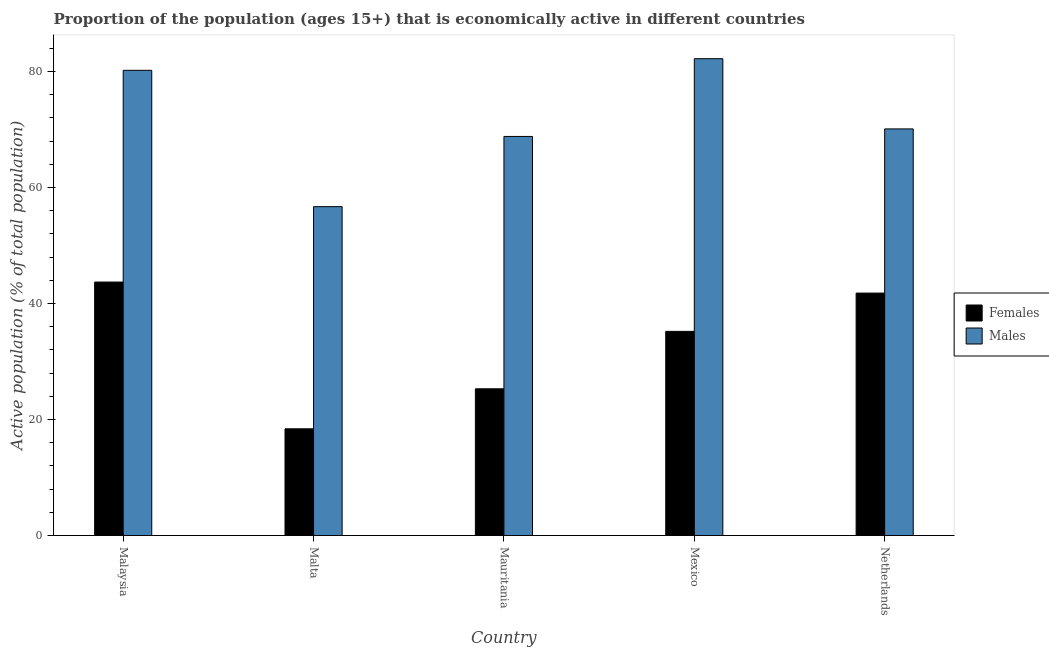How many groups of bars are there?
Provide a short and direct response. 5. What is the label of the 3rd group of bars from the left?
Provide a short and direct response. Mauritania. In how many cases, is the number of bars for a given country not equal to the number of legend labels?
Provide a succinct answer. 0. What is the percentage of economically active male population in Netherlands?
Provide a succinct answer. 70.1. Across all countries, what is the maximum percentage of economically active male population?
Your response must be concise. 82.2. Across all countries, what is the minimum percentage of economically active male population?
Keep it short and to the point. 56.7. In which country was the percentage of economically active male population maximum?
Offer a very short reply. Mexico. In which country was the percentage of economically active male population minimum?
Offer a terse response. Malta. What is the total percentage of economically active male population in the graph?
Keep it short and to the point. 358. What is the difference between the percentage of economically active female population in Mexico and the percentage of economically active male population in Mauritania?
Make the answer very short. -33.6. What is the average percentage of economically active male population per country?
Offer a very short reply. 71.6. What is the difference between the percentage of economically active male population and percentage of economically active female population in Malaysia?
Give a very brief answer. 36.5. In how many countries, is the percentage of economically active female population greater than 28 %?
Your response must be concise. 3. What is the ratio of the percentage of economically active male population in Mauritania to that in Mexico?
Provide a short and direct response. 0.84. Is the percentage of economically active female population in Malta less than that in Mexico?
Keep it short and to the point. Yes. What is the difference between the highest and the second highest percentage of economically active female population?
Your answer should be very brief. 1.9. What is the difference between the highest and the lowest percentage of economically active male population?
Provide a succinct answer. 25.5. In how many countries, is the percentage of economically active male population greater than the average percentage of economically active male population taken over all countries?
Give a very brief answer. 2. What does the 2nd bar from the left in Malaysia represents?
Give a very brief answer. Males. What does the 1st bar from the right in Mauritania represents?
Your answer should be compact. Males. How many bars are there?
Provide a short and direct response. 10. What is the difference between two consecutive major ticks on the Y-axis?
Your answer should be very brief. 20. Does the graph contain any zero values?
Your answer should be compact. No. What is the title of the graph?
Ensure brevity in your answer.  Proportion of the population (ages 15+) that is economically active in different countries. Does "Lower secondary education" appear as one of the legend labels in the graph?
Offer a very short reply. No. What is the label or title of the X-axis?
Provide a succinct answer. Country. What is the label or title of the Y-axis?
Keep it short and to the point. Active population (% of total population). What is the Active population (% of total population) of Females in Malaysia?
Provide a short and direct response. 43.7. What is the Active population (% of total population) of Males in Malaysia?
Your response must be concise. 80.2. What is the Active population (% of total population) in Females in Malta?
Provide a succinct answer. 18.4. What is the Active population (% of total population) of Males in Malta?
Give a very brief answer. 56.7. What is the Active population (% of total population) in Females in Mauritania?
Ensure brevity in your answer.  25.3. What is the Active population (% of total population) in Males in Mauritania?
Keep it short and to the point. 68.8. What is the Active population (% of total population) in Females in Mexico?
Make the answer very short. 35.2. What is the Active population (% of total population) in Males in Mexico?
Your response must be concise. 82.2. What is the Active population (% of total population) in Females in Netherlands?
Provide a short and direct response. 41.8. What is the Active population (% of total population) of Males in Netherlands?
Give a very brief answer. 70.1. Across all countries, what is the maximum Active population (% of total population) of Females?
Provide a short and direct response. 43.7. Across all countries, what is the maximum Active population (% of total population) in Males?
Keep it short and to the point. 82.2. Across all countries, what is the minimum Active population (% of total population) in Females?
Offer a terse response. 18.4. Across all countries, what is the minimum Active population (% of total population) of Males?
Your answer should be compact. 56.7. What is the total Active population (% of total population) of Females in the graph?
Ensure brevity in your answer.  164.4. What is the total Active population (% of total population) in Males in the graph?
Offer a very short reply. 358. What is the difference between the Active population (% of total population) of Females in Malaysia and that in Malta?
Give a very brief answer. 25.3. What is the difference between the Active population (% of total population) of Males in Malaysia and that in Malta?
Offer a very short reply. 23.5. What is the difference between the Active population (% of total population) in Females in Malaysia and that in Mauritania?
Ensure brevity in your answer.  18.4. What is the difference between the Active population (% of total population) in Males in Malaysia and that in Mauritania?
Your response must be concise. 11.4. What is the difference between the Active population (% of total population) of Females in Malaysia and that in Mexico?
Your answer should be compact. 8.5. What is the difference between the Active population (% of total population) in Males in Malaysia and that in Mexico?
Provide a succinct answer. -2. What is the difference between the Active population (% of total population) in Males in Malaysia and that in Netherlands?
Provide a succinct answer. 10.1. What is the difference between the Active population (% of total population) in Males in Malta and that in Mauritania?
Provide a short and direct response. -12.1. What is the difference between the Active population (% of total population) in Females in Malta and that in Mexico?
Offer a terse response. -16.8. What is the difference between the Active population (% of total population) in Males in Malta and that in Mexico?
Make the answer very short. -25.5. What is the difference between the Active population (% of total population) in Females in Malta and that in Netherlands?
Give a very brief answer. -23.4. What is the difference between the Active population (% of total population) in Males in Malta and that in Netherlands?
Your answer should be very brief. -13.4. What is the difference between the Active population (% of total population) of Females in Mauritania and that in Mexico?
Your answer should be compact. -9.9. What is the difference between the Active population (% of total population) in Females in Mauritania and that in Netherlands?
Provide a succinct answer. -16.5. What is the difference between the Active population (% of total population) of Males in Mauritania and that in Netherlands?
Your answer should be compact. -1.3. What is the difference between the Active population (% of total population) of Females in Malaysia and the Active population (% of total population) of Males in Malta?
Offer a very short reply. -13. What is the difference between the Active population (% of total population) of Females in Malaysia and the Active population (% of total population) of Males in Mauritania?
Offer a terse response. -25.1. What is the difference between the Active population (% of total population) in Females in Malaysia and the Active population (% of total population) in Males in Mexico?
Provide a succinct answer. -38.5. What is the difference between the Active population (% of total population) of Females in Malaysia and the Active population (% of total population) of Males in Netherlands?
Your answer should be very brief. -26.4. What is the difference between the Active population (% of total population) of Females in Malta and the Active population (% of total population) of Males in Mauritania?
Your answer should be very brief. -50.4. What is the difference between the Active population (% of total population) of Females in Malta and the Active population (% of total population) of Males in Mexico?
Make the answer very short. -63.8. What is the difference between the Active population (% of total population) of Females in Malta and the Active population (% of total population) of Males in Netherlands?
Make the answer very short. -51.7. What is the difference between the Active population (% of total population) of Females in Mauritania and the Active population (% of total population) of Males in Mexico?
Your answer should be compact. -56.9. What is the difference between the Active population (% of total population) in Females in Mauritania and the Active population (% of total population) in Males in Netherlands?
Ensure brevity in your answer.  -44.8. What is the difference between the Active population (% of total population) of Females in Mexico and the Active population (% of total population) of Males in Netherlands?
Give a very brief answer. -34.9. What is the average Active population (% of total population) of Females per country?
Your response must be concise. 32.88. What is the average Active population (% of total population) in Males per country?
Provide a short and direct response. 71.6. What is the difference between the Active population (% of total population) in Females and Active population (% of total population) in Males in Malaysia?
Offer a very short reply. -36.5. What is the difference between the Active population (% of total population) in Females and Active population (% of total population) in Males in Malta?
Make the answer very short. -38.3. What is the difference between the Active population (% of total population) of Females and Active population (% of total population) of Males in Mauritania?
Give a very brief answer. -43.5. What is the difference between the Active population (% of total population) in Females and Active population (% of total population) in Males in Mexico?
Make the answer very short. -47. What is the difference between the Active population (% of total population) in Females and Active population (% of total population) in Males in Netherlands?
Provide a short and direct response. -28.3. What is the ratio of the Active population (% of total population) in Females in Malaysia to that in Malta?
Ensure brevity in your answer.  2.38. What is the ratio of the Active population (% of total population) in Males in Malaysia to that in Malta?
Your answer should be compact. 1.41. What is the ratio of the Active population (% of total population) of Females in Malaysia to that in Mauritania?
Ensure brevity in your answer.  1.73. What is the ratio of the Active population (% of total population) in Males in Malaysia to that in Mauritania?
Your response must be concise. 1.17. What is the ratio of the Active population (% of total population) of Females in Malaysia to that in Mexico?
Provide a succinct answer. 1.24. What is the ratio of the Active population (% of total population) of Males in Malaysia to that in Mexico?
Keep it short and to the point. 0.98. What is the ratio of the Active population (% of total population) of Females in Malaysia to that in Netherlands?
Ensure brevity in your answer.  1.05. What is the ratio of the Active population (% of total population) in Males in Malaysia to that in Netherlands?
Ensure brevity in your answer.  1.14. What is the ratio of the Active population (% of total population) in Females in Malta to that in Mauritania?
Give a very brief answer. 0.73. What is the ratio of the Active population (% of total population) in Males in Malta to that in Mauritania?
Offer a very short reply. 0.82. What is the ratio of the Active population (% of total population) in Females in Malta to that in Mexico?
Provide a short and direct response. 0.52. What is the ratio of the Active population (% of total population) of Males in Malta to that in Mexico?
Offer a terse response. 0.69. What is the ratio of the Active population (% of total population) in Females in Malta to that in Netherlands?
Offer a terse response. 0.44. What is the ratio of the Active population (% of total population) of Males in Malta to that in Netherlands?
Your answer should be compact. 0.81. What is the ratio of the Active population (% of total population) of Females in Mauritania to that in Mexico?
Ensure brevity in your answer.  0.72. What is the ratio of the Active population (% of total population) in Males in Mauritania to that in Mexico?
Provide a short and direct response. 0.84. What is the ratio of the Active population (% of total population) in Females in Mauritania to that in Netherlands?
Your response must be concise. 0.61. What is the ratio of the Active population (% of total population) of Males in Mauritania to that in Netherlands?
Your answer should be very brief. 0.98. What is the ratio of the Active population (% of total population) in Females in Mexico to that in Netherlands?
Offer a terse response. 0.84. What is the ratio of the Active population (% of total population) of Males in Mexico to that in Netherlands?
Offer a very short reply. 1.17. What is the difference between the highest and the second highest Active population (% of total population) in Males?
Ensure brevity in your answer.  2. What is the difference between the highest and the lowest Active population (% of total population) in Females?
Keep it short and to the point. 25.3. 